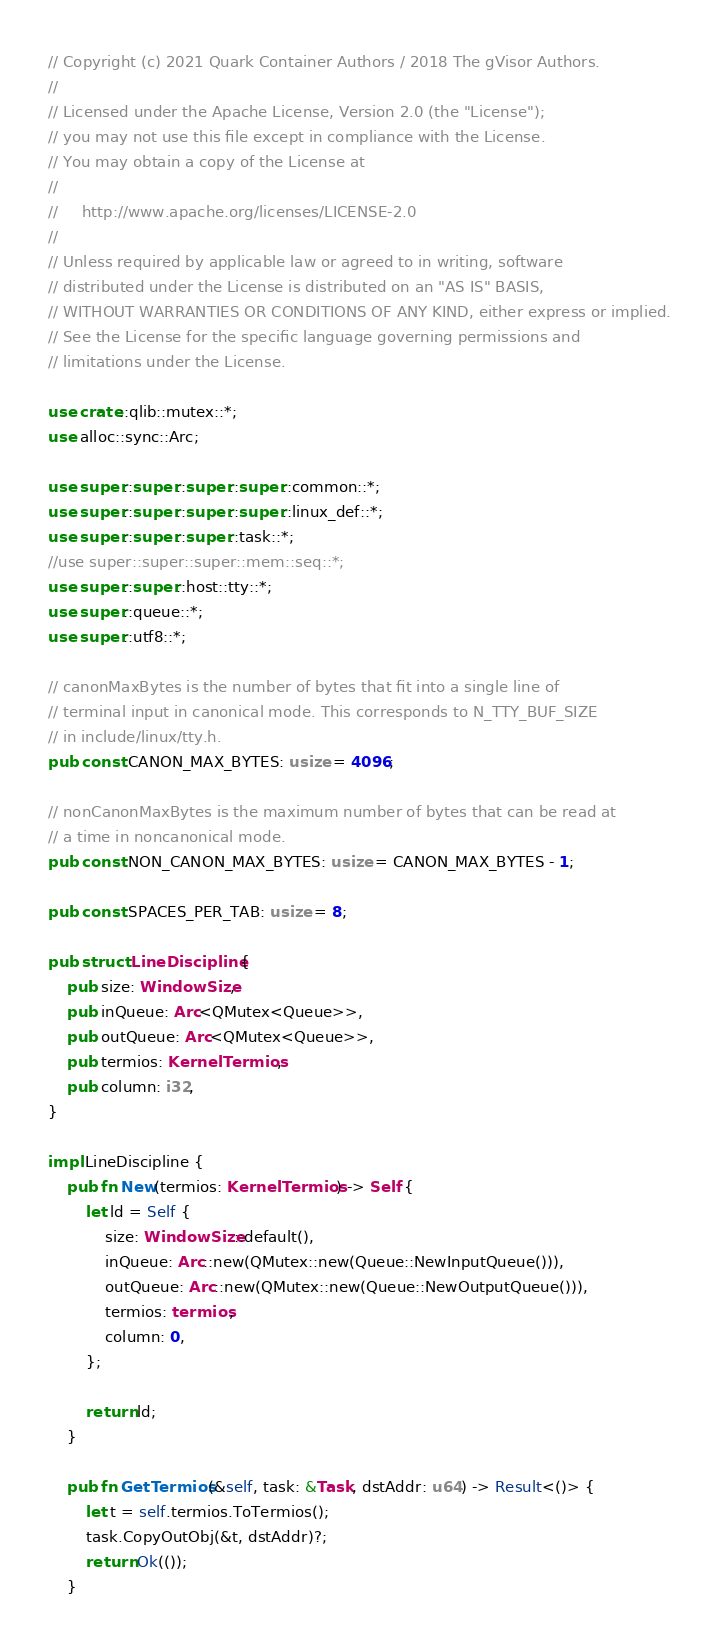Convert code to text. <code><loc_0><loc_0><loc_500><loc_500><_Rust_>// Copyright (c) 2021 Quark Container Authors / 2018 The gVisor Authors.
//
// Licensed under the Apache License, Version 2.0 (the "License");
// you may not use this file except in compliance with the License.
// You may obtain a copy of the License at
//
//     http://www.apache.org/licenses/LICENSE-2.0
//
// Unless required by applicable law or agreed to in writing, software
// distributed under the License is distributed on an "AS IS" BASIS,
// WITHOUT WARRANTIES OR CONDITIONS OF ANY KIND, either express or implied.
// See the License for the specific language governing permissions and
// limitations under the License.

use crate::qlib::mutex::*;
use alloc::sync::Arc;

use super::super::super::super::common::*;
use super::super::super::super::linux_def::*;
use super::super::super::task::*;
//use super::super::super::mem::seq::*;
use super::super::host::tty::*;
use super::queue::*;
use super::utf8::*;

// canonMaxBytes is the number of bytes that fit into a single line of
// terminal input in canonical mode. This corresponds to N_TTY_BUF_SIZE
// in include/linux/tty.h.
pub const CANON_MAX_BYTES: usize = 4096;

// nonCanonMaxBytes is the maximum number of bytes that can be read at
// a time in noncanonical mode.
pub const NON_CANON_MAX_BYTES: usize = CANON_MAX_BYTES - 1;

pub const SPACES_PER_TAB: usize = 8;

pub struct LineDiscipline {
    pub size: WindowSize,
    pub inQueue: Arc<QMutex<Queue>>,
    pub outQueue: Arc<QMutex<Queue>>,
    pub termios: KernelTermios,
    pub column: i32,
}

impl LineDiscipline {
    pub fn New(termios: KernelTermios) -> Self {
        let ld = Self {
            size: WindowSize::default(),
            inQueue: Arc::new(QMutex::new(Queue::NewInputQueue())),
            outQueue: Arc::new(QMutex::new(Queue::NewOutputQueue())),
            termios: termios,
            column: 0,
        };

        return ld;
    }

    pub fn GetTermios(&self, task: &Task, dstAddr: u64) -> Result<()> {
        let t = self.termios.ToTermios();
        task.CopyOutObj(&t, dstAddr)?;
        return Ok(());
    }
</code> 